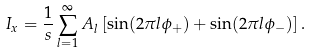Convert formula to latex. <formula><loc_0><loc_0><loc_500><loc_500>I _ { x } = \frac { 1 } { s } \sum _ { l = 1 } ^ { \infty } A _ { l } \left [ \sin ( 2 \pi l \phi _ { + } ) + \sin ( 2 \pi l \phi _ { - } ) \right ] .</formula> 